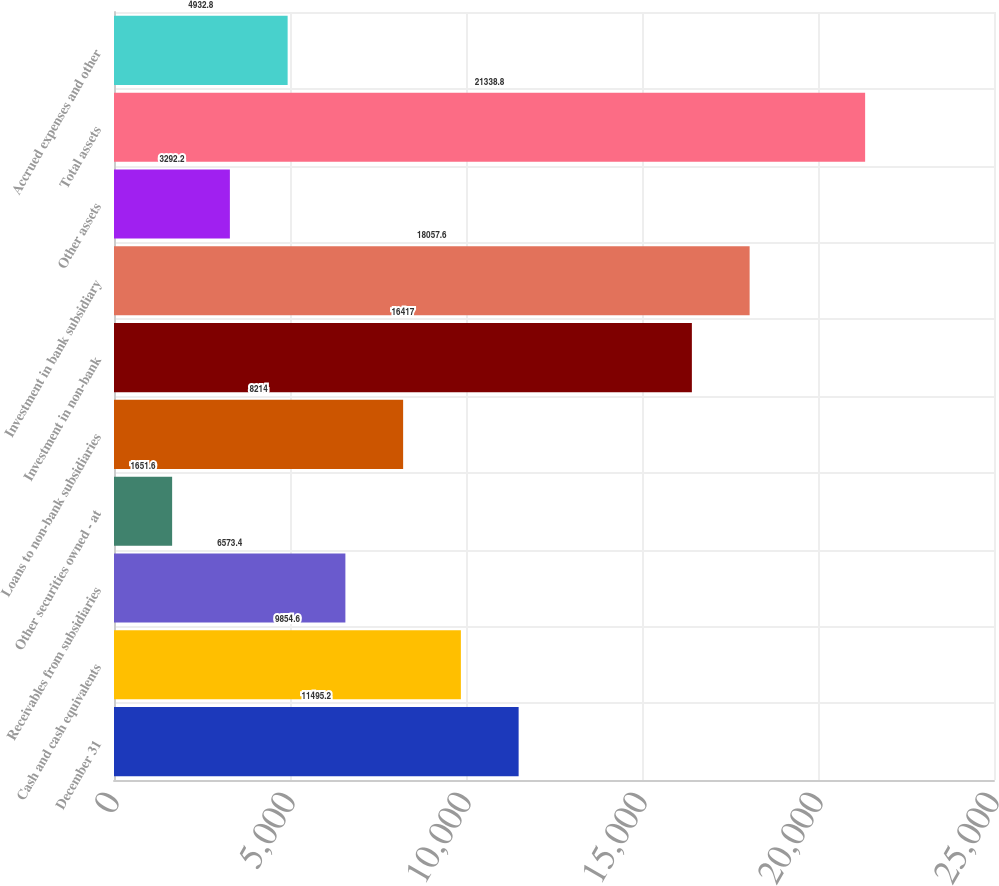Convert chart. <chart><loc_0><loc_0><loc_500><loc_500><bar_chart><fcel>December 31<fcel>Cash and cash equivalents<fcel>Receivables from subsidiaries<fcel>Other securities owned - at<fcel>Loans to non-bank subsidiaries<fcel>Investment in non-bank<fcel>Investment in bank subsidiary<fcel>Other assets<fcel>Total assets<fcel>Accrued expenses and other<nl><fcel>11495.2<fcel>9854.6<fcel>6573.4<fcel>1651.6<fcel>8214<fcel>16417<fcel>18057.6<fcel>3292.2<fcel>21338.8<fcel>4932.8<nl></chart> 